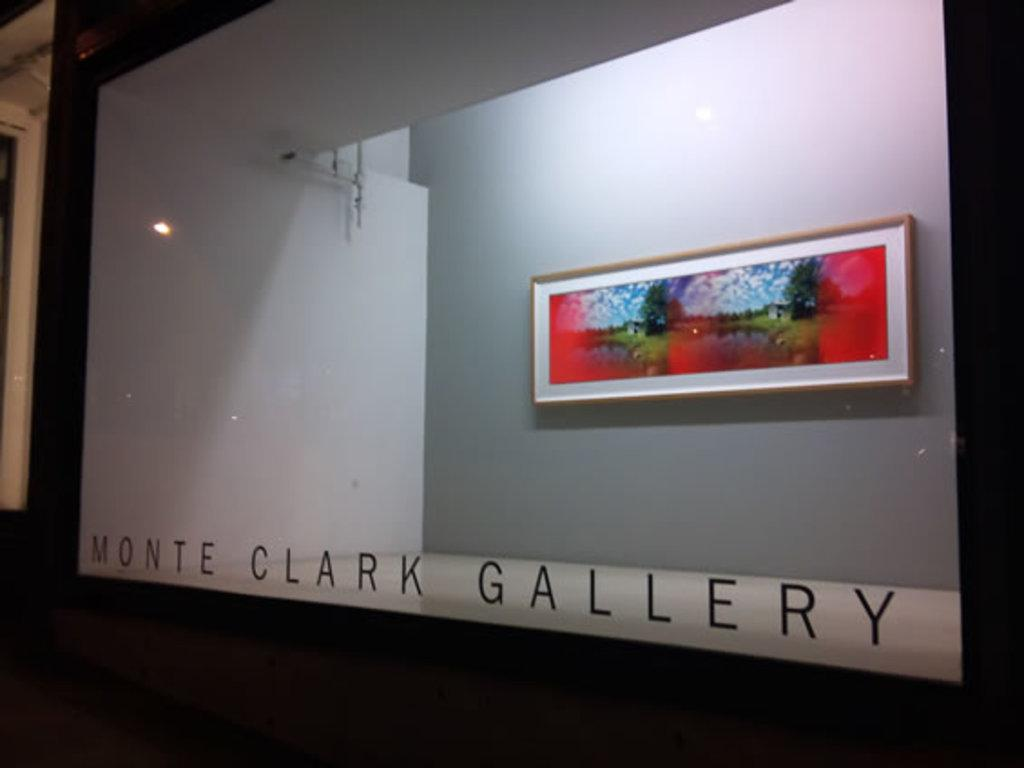<image>
Share a concise interpretation of the image provided. Picture on a wall above some words that say "Monte Clark Gallery". 